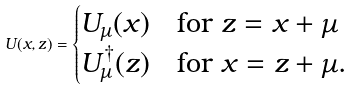Convert formula to latex. <formula><loc_0><loc_0><loc_500><loc_500>U ( x , z ) = \begin{cases} U _ { \mu } ( x ) & \text {for $z=x+\mu$} \\ U ^ { \dagger } _ { \mu } ( z ) & \text {for $x=z+\mu$.} \end{cases}</formula> 